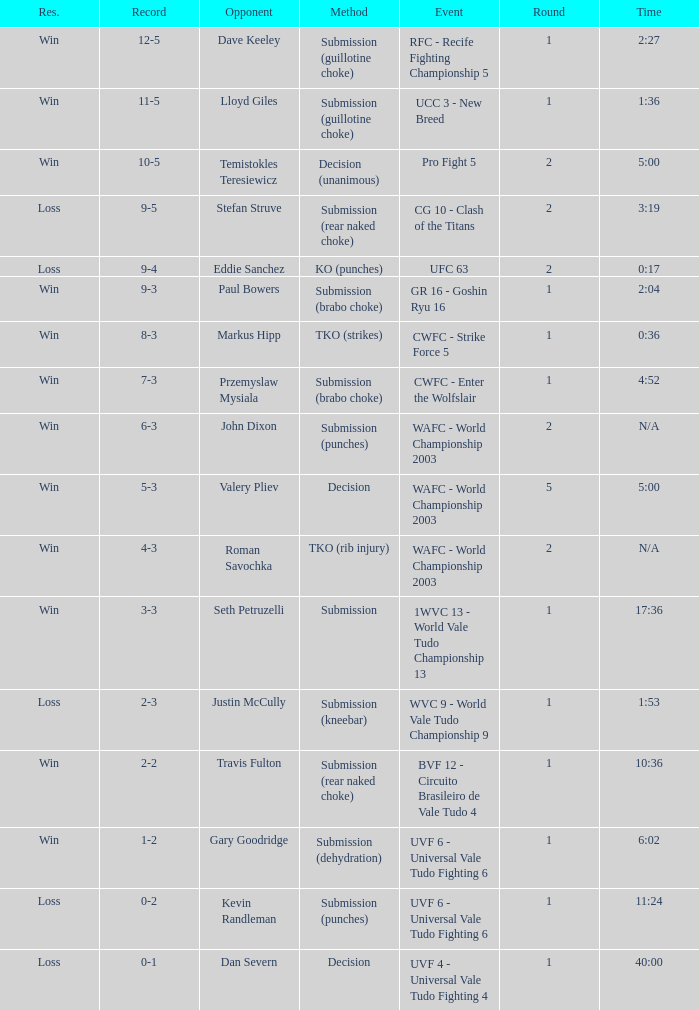What opponent uses the method of decision and a 5-3 record? Valery Pliev. 